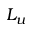<formula> <loc_0><loc_0><loc_500><loc_500>L _ { u }</formula> 